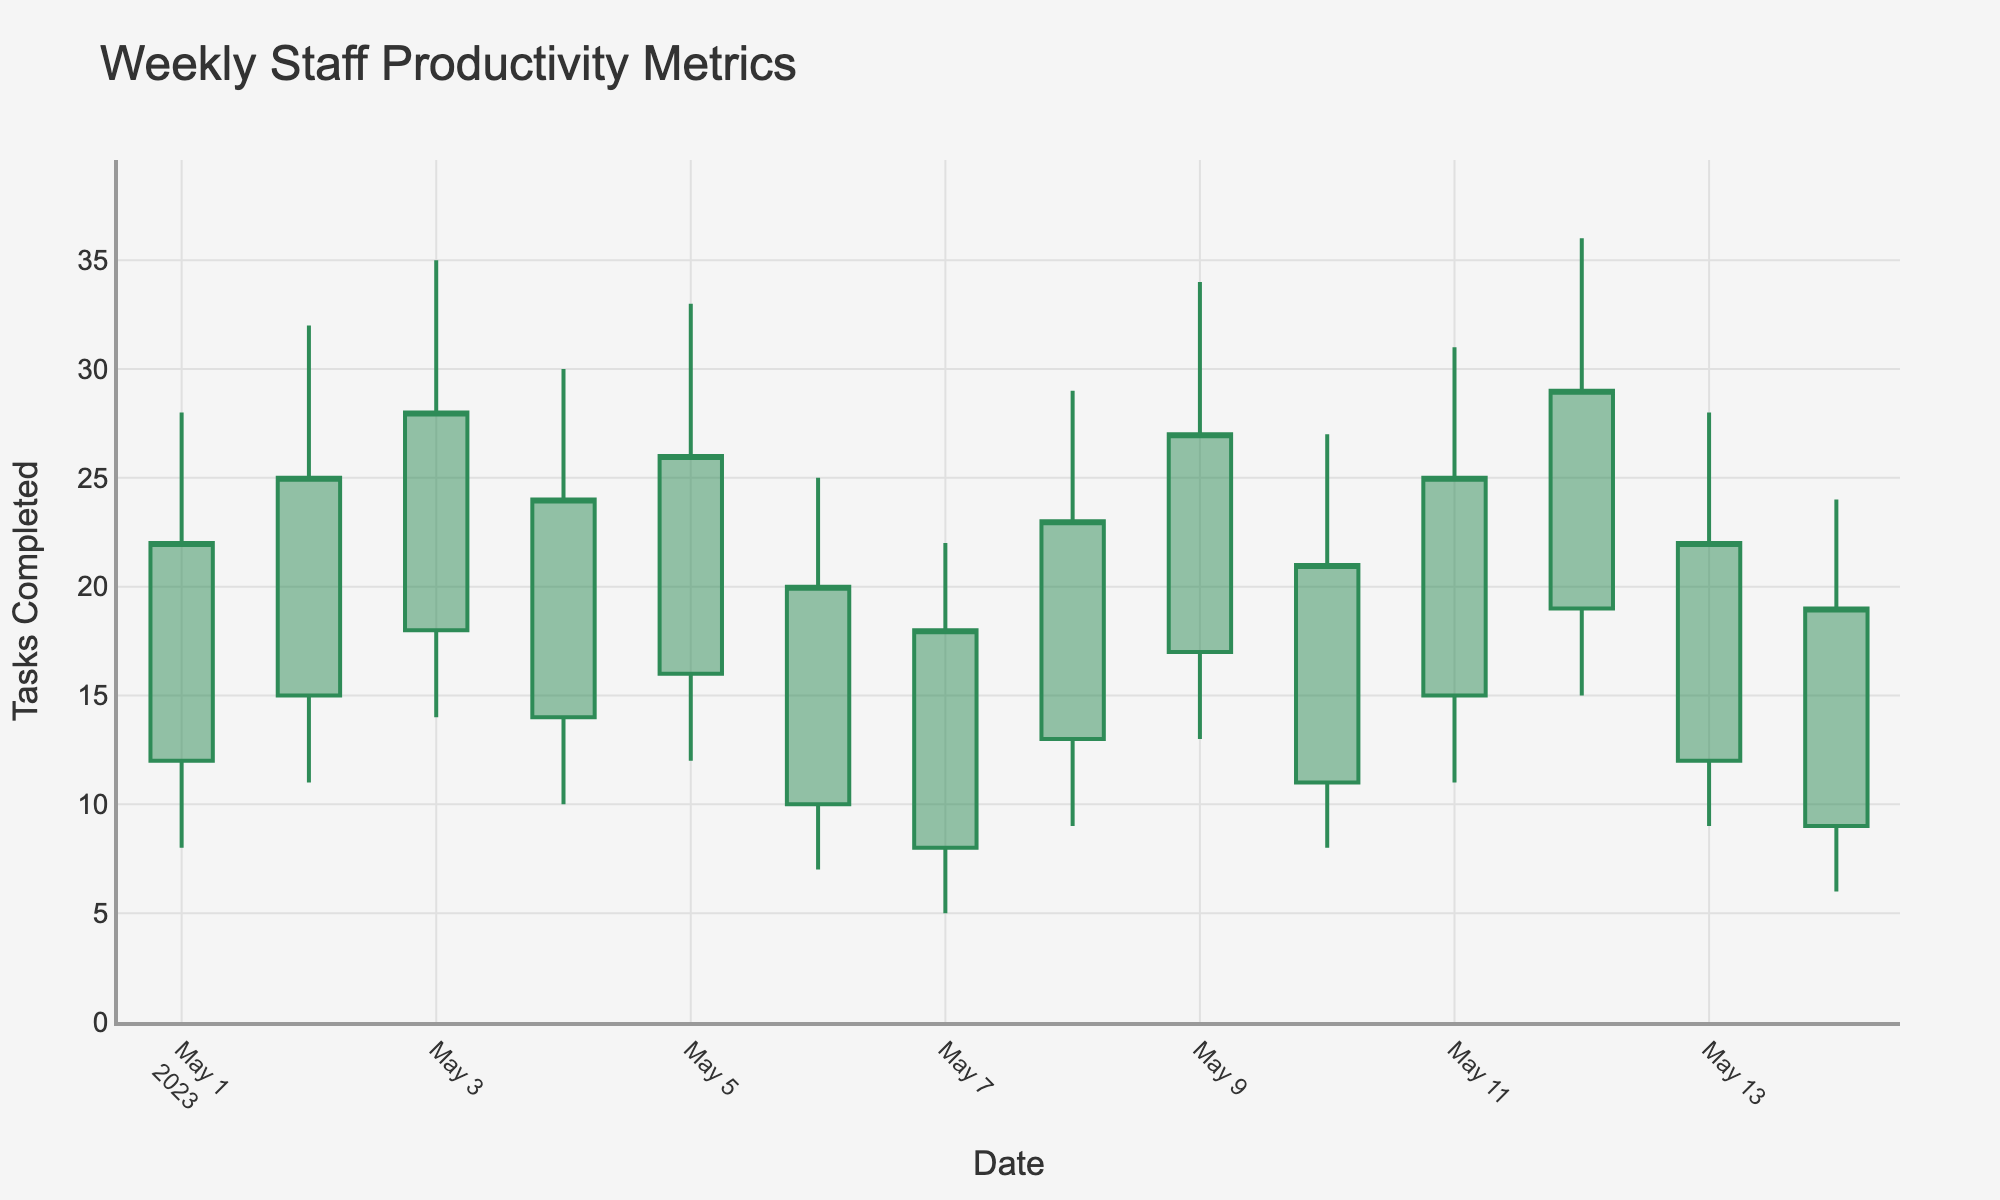What's the title of the chart? The title of the chart is typically displayed prominently at the top of the image, often with a larger or bold font. In this case, we can see the title clearly written.
Answer: Weekly Staff Productivity Metrics What are the labels for the x-axis and y-axis? These labels are usually found near the axes. The x-axis label is at the bottom, and the y-axis label is on the left side of the chart. In this chart, they are labeled accordingly.
Answer: x-axis: Date, y-axis: Tasks Completed On which date did the staff have the highest peak performance? To find this, look for the tallest candle on the chart, which represents the highest value reached on a specific date. The tallest candlestick indicates May 12th.
Answer: 2023-05-12 What is the range of tasks completed on 2023-05-05? The range is the difference between the highest (Peak) and lowest (Low) points on that day. On 2023-05-05, the highest is 33, and the lowest is 12. So, the range is 33 - 12.
Answer: 21 What is the average number of tasks completed at the start of the day from May 1st to May 14th? Sum the 'Start' values from May 1st to May 14th, then divide by the number of days (14). Start values: 12+15+18+14+16+10+8+13+17+11+15+19+12+9 = 189. Average = 189/14.
Answer: 13.5 Which day shows the greatest productivity variation throughout the day? Productivity variation can be seen by the difference between the high (Peak) and low (Low) of the day. The day with the largest difference between these two values is May 12th (36 - 15).
Answer: 2023-05-12 Compare the number of tasks completed by the end of the day on May 3rd and May 7th. Which day had more tasks completed? Look at the 'End' values for both dates. May 3rd shows an 'End' value of 28, while May 7th shows 18.
Answer: May 3rd How does the productivity trend change from May 10th to May 12th? Analyzing the trends on May 10th, 11th, and 12th shows the start, peak, low, and end values. On May 10th, the peak is 27, on May 11th is 31, and on May 12th is 36, indicating an increasing trend. Similarly, the end values also increase.
Answer: Increasing trend What was the peak and low productivity on May 8th? Check the candlestick for May 8th, noting the highest and lowest points. The peak is 29, and the low is 9.
Answer: Peak: 29, Low: 9 What is the color difference between increasing and decreasing lines? Look at the lines of the candlestick chart. Typically, increasing lines are green or dark green, and decreasing lines are red or dark red. In this chart, increasing lines are forest green and decreasing lines are dark red.
Answer: Increasing: forest green, Decreasing: dark red 